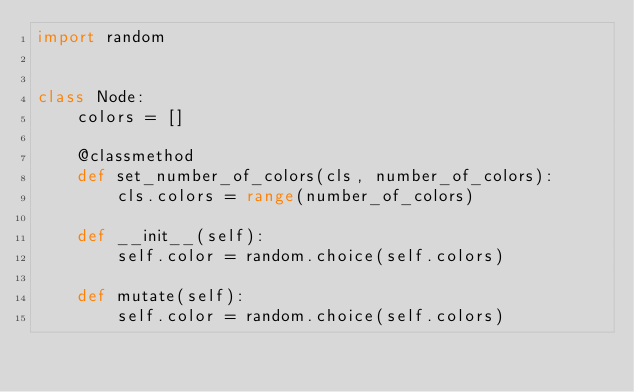Convert code to text. <code><loc_0><loc_0><loc_500><loc_500><_Python_>import random


class Node:
    colors = []

    @classmethod
    def set_number_of_colors(cls, number_of_colors):
        cls.colors = range(number_of_colors)

    def __init__(self):
        self.color = random.choice(self.colors)

    def mutate(self):
        self.color = random.choice(self.colors)
</code> 